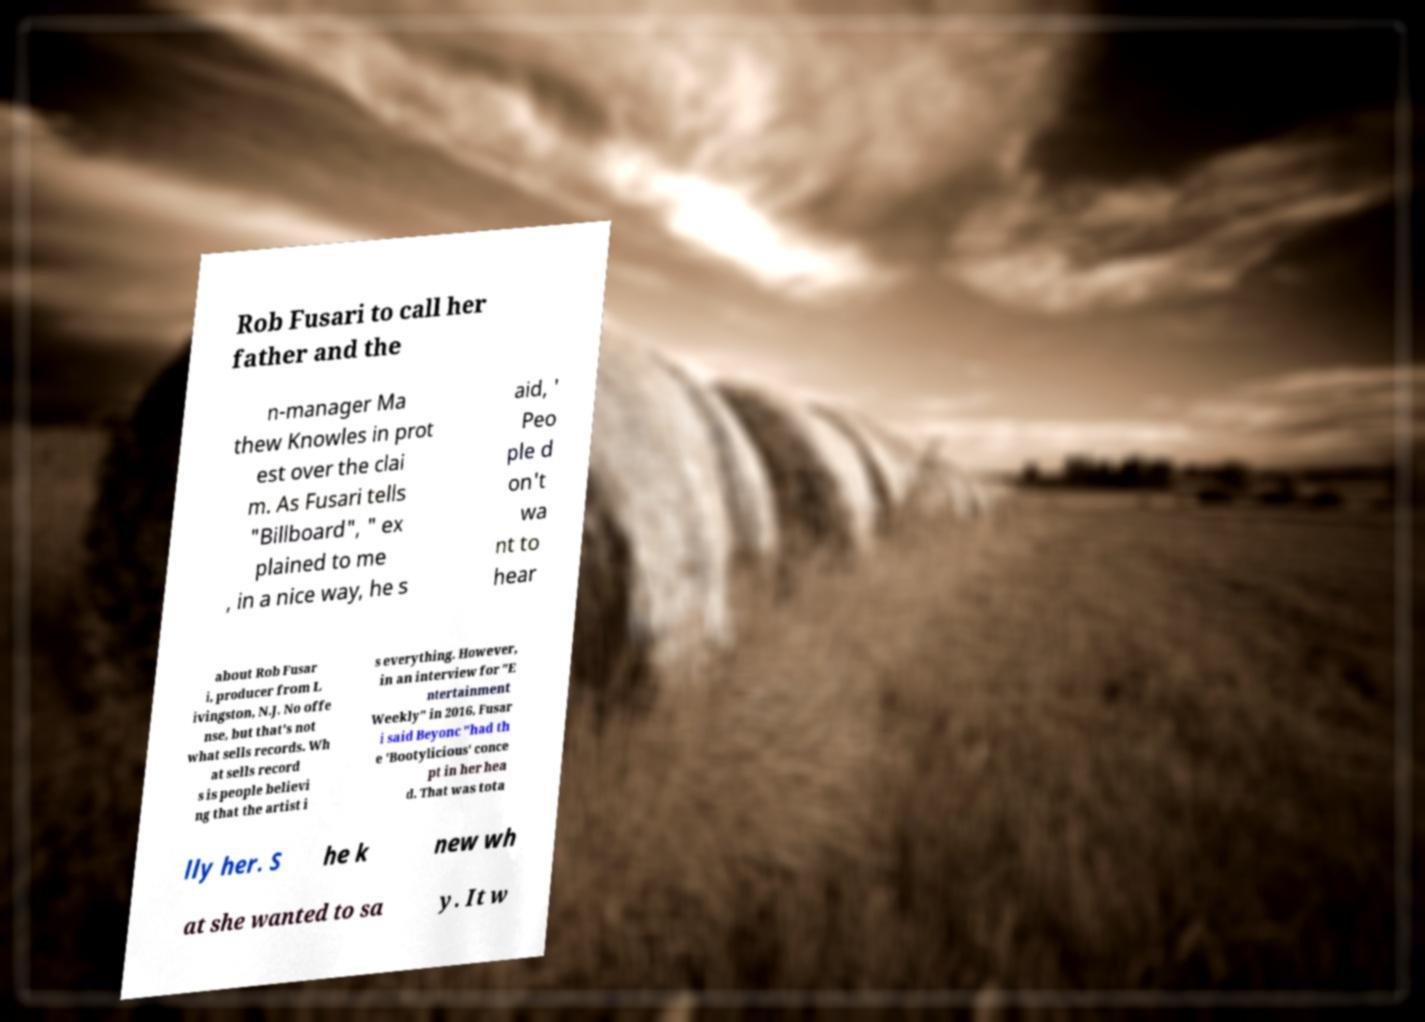Can you read and provide the text displayed in the image?This photo seems to have some interesting text. Can you extract and type it out for me? Rob Fusari to call her father and the n-manager Ma thew Knowles in prot est over the clai m. As Fusari tells "Billboard", " ex plained to me , in a nice way, he s aid, ' Peo ple d on't wa nt to hear about Rob Fusar i, producer from L ivingston, N.J. No offe nse, but that's not what sells records. Wh at sells record s is people believi ng that the artist i s everything. However, in an interview for "E ntertainment Weekly" in 2016, Fusar i said Beyonc "had th e 'Bootylicious' conce pt in her hea d. That was tota lly her. S he k new wh at she wanted to sa y. It w 